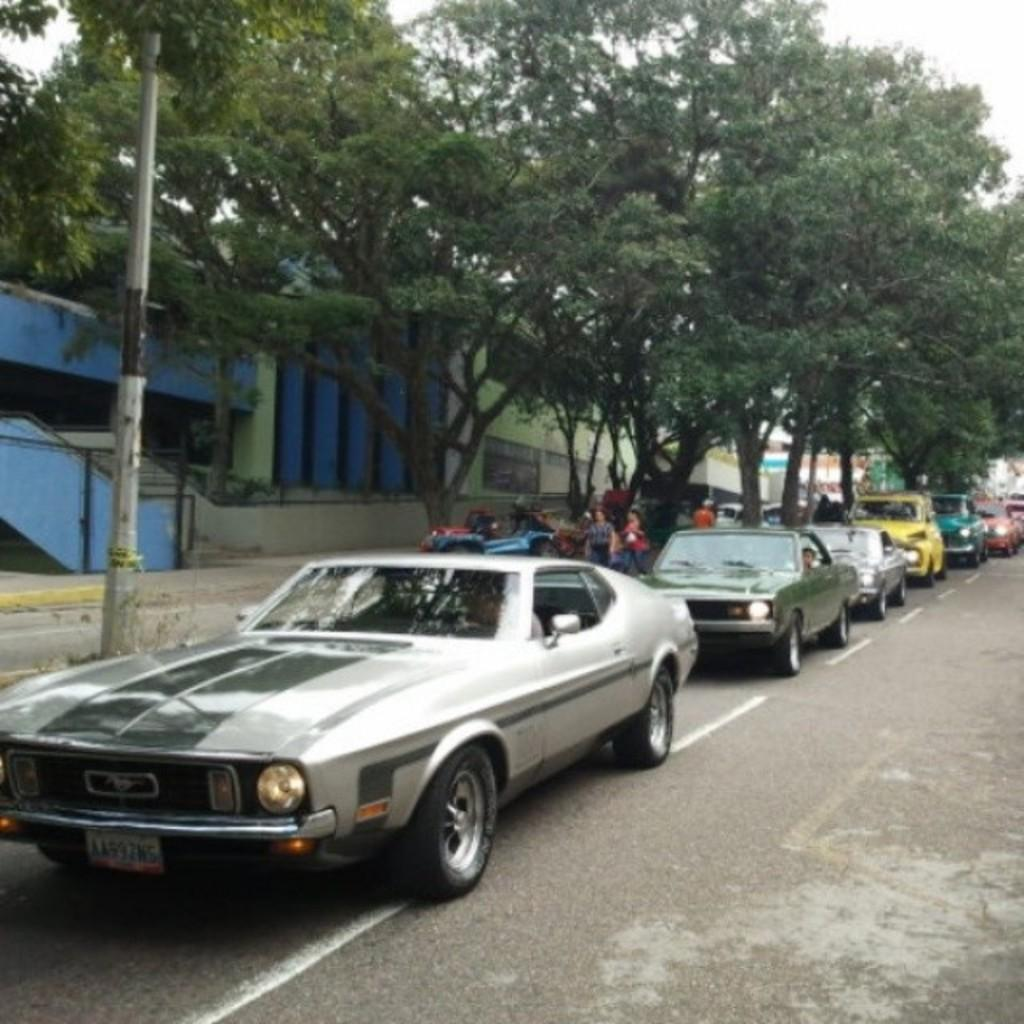What type of vehicles can be seen in the image? There are cars in the image. What type of vegetation is present in the image? There are green trees in the image. What type of pie is being served at the development site in the image? There is no development site or pie present in the image; it features cars and green trees. What type of pleasure can be derived from the image? The image does not convey a specific type of pleasure; it simply shows cars and green trees. 